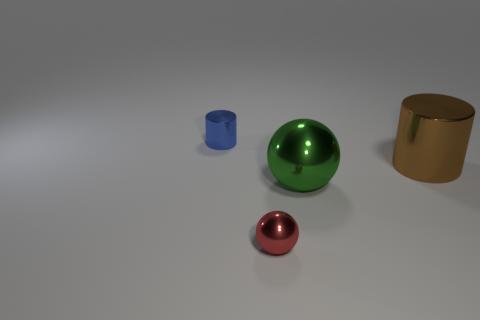Subtract 1 cylinders. How many cylinders are left? 1 Add 4 gray shiny objects. How many gray shiny objects exist? 4 Add 2 green things. How many objects exist? 6 Subtract all green balls. How many balls are left? 1 Subtract 0 green cylinders. How many objects are left? 4 Subtract all brown spheres. Subtract all green blocks. How many spheres are left? 2 Subtract all cyan cylinders. How many red balls are left? 1 Subtract all red spheres. Subtract all large green metal blocks. How many objects are left? 3 Add 1 tiny balls. How many tiny balls are left? 2 